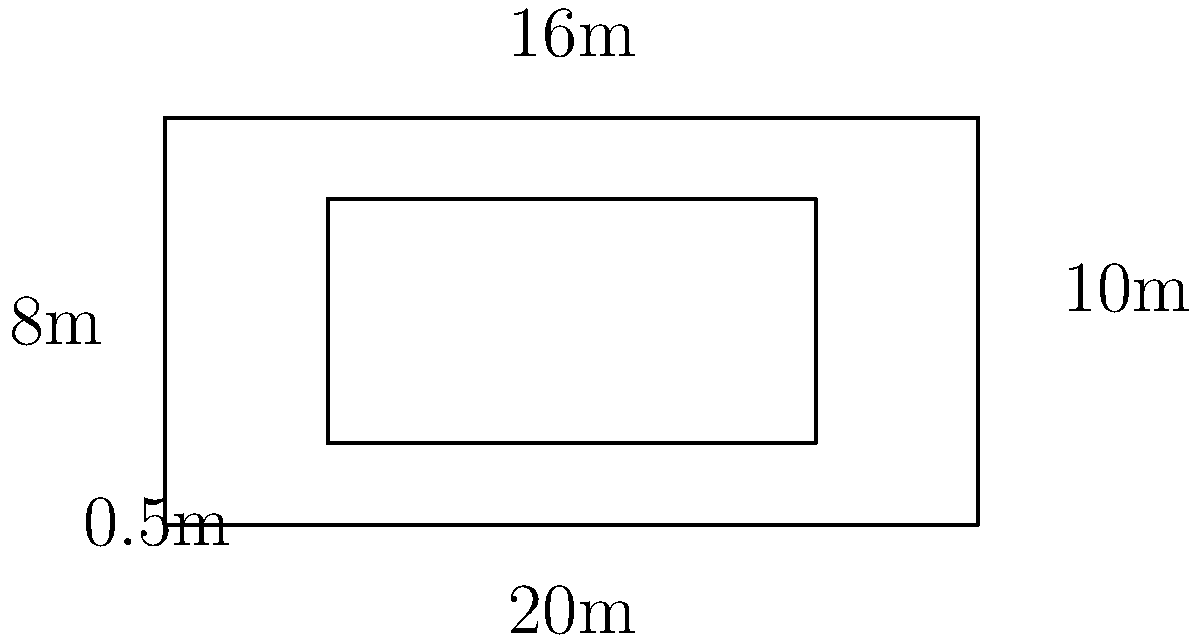As a strategic marketer for a construction startup, you need to estimate the amount of concrete needed for a building foundation. Given the blueprint above, where the outer rectangle represents the plot and the inner rectangle represents the foundation area, calculate the volume of concrete required if the foundation depth is 0.5m. Assume the concrete extends to the edges of the inner rectangle. To calculate the volume of concrete needed, we'll follow these steps:

1. Calculate the area of the foundation:
   Length of foundation = 16m
   Width of foundation = 6m
   Area = $16m \times 6m = 96m^2$

2. Calculate the volume of concrete:
   Volume = Area × Depth
   $V = 96m^2 \times 0.5m = 48m^3$

3. Convert cubic meters to cubic yards (common unit for concrete orders):
   1 cubic meter = 1.30795 cubic yards
   $48m^3 \times 1.30795 = 62.78$ cubic yards

4. Round up to the nearest whole number for practical ordering:
   63 cubic yards

This calculation provides a basis for estimating concrete costs and logistics for the marketing campaign, ensuring accurate communication with potential clients about project requirements and pricing.
Answer: 63 cubic yards 